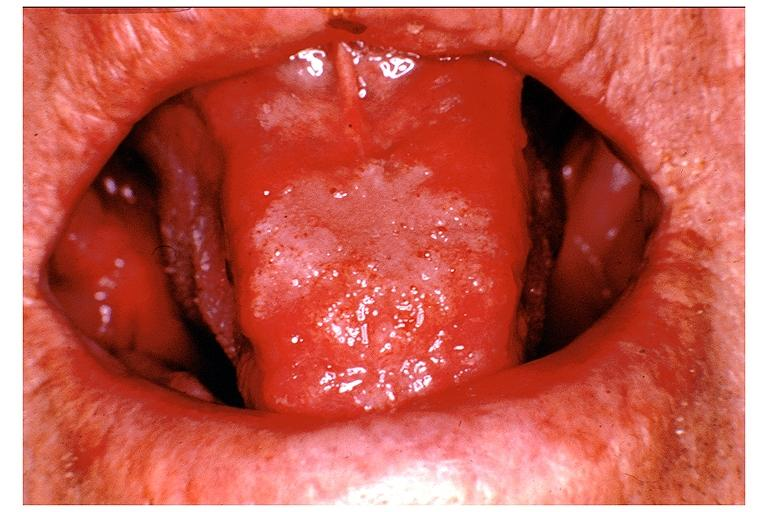s oral present?
Answer the question using a single word or phrase. Yes 